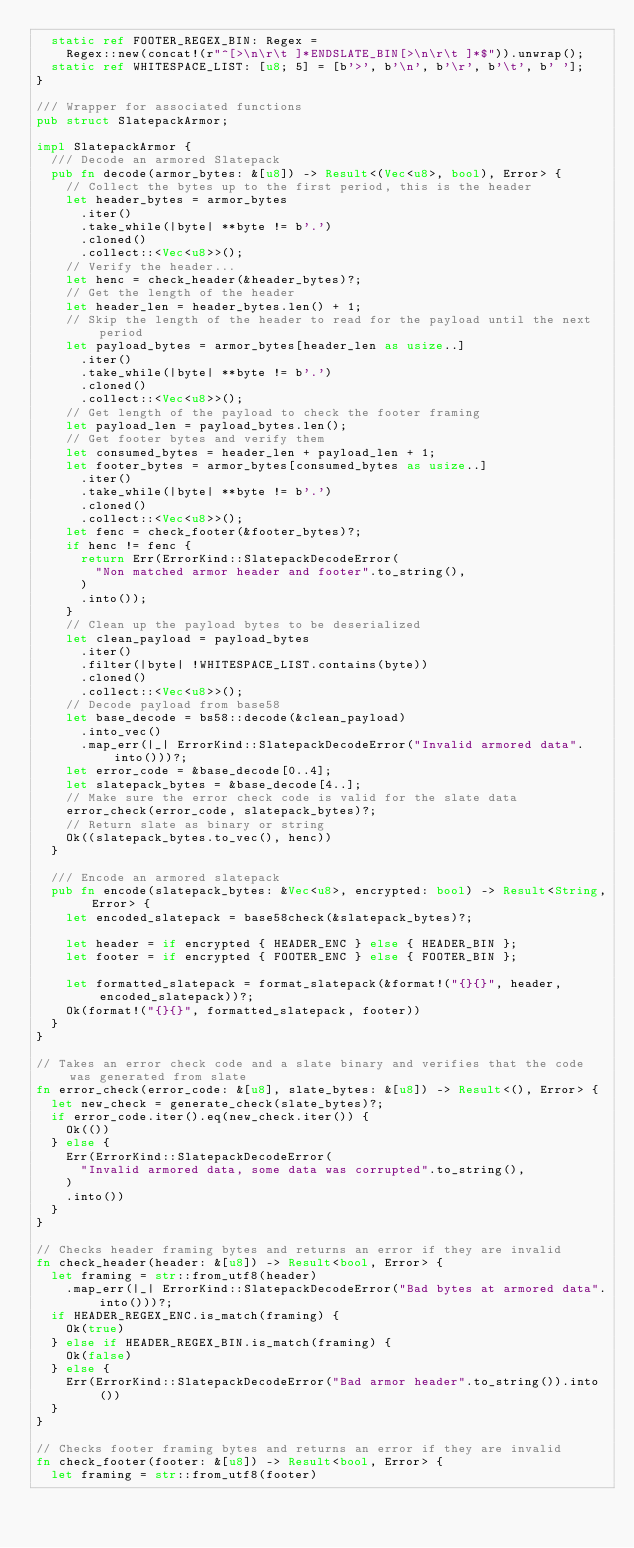Convert code to text. <code><loc_0><loc_0><loc_500><loc_500><_Rust_>	static ref FOOTER_REGEX_BIN: Regex =
		Regex::new(concat!(r"^[>\n\r\t ]*ENDSLATE_BIN[>\n\r\t ]*$")).unwrap();
	static ref WHITESPACE_LIST: [u8; 5] = [b'>', b'\n', b'\r', b'\t', b' '];
}

/// Wrapper for associated functions
pub struct SlatepackArmor;

impl SlatepackArmor {
	/// Decode an armored Slatepack
	pub fn decode(armor_bytes: &[u8]) -> Result<(Vec<u8>, bool), Error> {
		// Collect the bytes up to the first period, this is the header
		let header_bytes = armor_bytes
			.iter()
			.take_while(|byte| **byte != b'.')
			.cloned()
			.collect::<Vec<u8>>();
		// Verify the header...
		let henc = check_header(&header_bytes)?;
		// Get the length of the header
		let header_len = header_bytes.len() + 1;
		// Skip the length of the header to read for the payload until the next period
		let payload_bytes = armor_bytes[header_len as usize..]
			.iter()
			.take_while(|byte| **byte != b'.')
			.cloned()
			.collect::<Vec<u8>>();
		// Get length of the payload to check the footer framing
		let payload_len = payload_bytes.len();
		// Get footer bytes and verify them
		let consumed_bytes = header_len + payload_len + 1;
		let footer_bytes = armor_bytes[consumed_bytes as usize..]
			.iter()
			.take_while(|byte| **byte != b'.')
			.cloned()
			.collect::<Vec<u8>>();
		let fenc = check_footer(&footer_bytes)?;
		if henc != fenc {
			return Err(ErrorKind::SlatepackDecodeError(
				"Non matched armor header and footer".to_string(),
			)
			.into());
		}
		// Clean up the payload bytes to be deserialized
		let clean_payload = payload_bytes
			.iter()
			.filter(|byte| !WHITESPACE_LIST.contains(byte))
			.cloned()
			.collect::<Vec<u8>>();
		// Decode payload from base58
		let base_decode = bs58::decode(&clean_payload)
			.into_vec()
			.map_err(|_| ErrorKind::SlatepackDecodeError("Invalid armored data".into()))?;
		let error_code = &base_decode[0..4];
		let slatepack_bytes = &base_decode[4..];
		// Make sure the error check code is valid for the slate data
		error_check(error_code, slatepack_bytes)?;
		// Return slate as binary or string
		Ok((slatepack_bytes.to_vec(), henc))
	}

	/// Encode an armored slatepack
	pub fn encode(slatepack_bytes: &Vec<u8>, encrypted: bool) -> Result<String, Error> {
		let encoded_slatepack = base58check(&slatepack_bytes)?;

		let header = if encrypted { HEADER_ENC } else { HEADER_BIN };
		let footer = if encrypted { FOOTER_ENC } else { FOOTER_BIN };

		let formatted_slatepack = format_slatepack(&format!("{}{}", header, encoded_slatepack))?;
		Ok(format!("{}{}", formatted_slatepack, footer))
	}
}

// Takes an error check code and a slate binary and verifies that the code was generated from slate
fn error_check(error_code: &[u8], slate_bytes: &[u8]) -> Result<(), Error> {
	let new_check = generate_check(slate_bytes)?;
	if error_code.iter().eq(new_check.iter()) {
		Ok(())
	} else {
		Err(ErrorKind::SlatepackDecodeError(
			"Invalid armored data, some data was corrupted".to_string(),
		)
		.into())
	}
}

// Checks header framing bytes and returns an error if they are invalid
fn check_header(header: &[u8]) -> Result<bool, Error> {
	let framing = str::from_utf8(header)
		.map_err(|_| ErrorKind::SlatepackDecodeError("Bad bytes at armored data".into()))?;
	if HEADER_REGEX_ENC.is_match(framing) {
		Ok(true)
	} else if HEADER_REGEX_BIN.is_match(framing) {
		Ok(false)
	} else {
		Err(ErrorKind::SlatepackDecodeError("Bad armor header".to_string()).into())
	}
}

// Checks footer framing bytes and returns an error if they are invalid
fn check_footer(footer: &[u8]) -> Result<bool, Error> {
	let framing = str::from_utf8(footer)</code> 